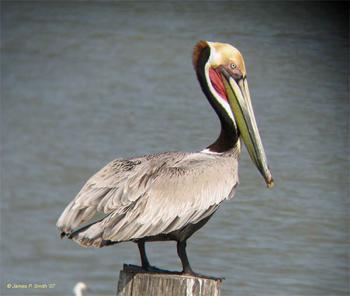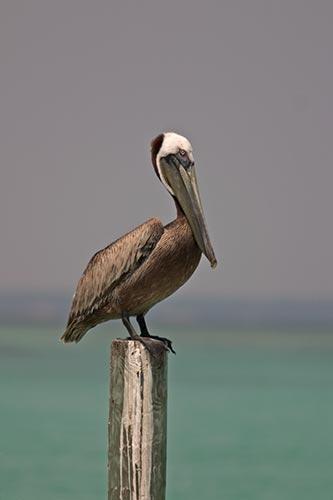The first image is the image on the left, the second image is the image on the right. Examine the images to the left and right. Is the description "In the left image, a pelican is facing right and sitting with its neck buried in its body." accurate? Answer yes or no. No. The first image is the image on the left, the second image is the image on the right. For the images shown, is this caption "Each image shows one pelican perched on a post, and at least one of the birds depicted is facing rightward." true? Answer yes or no. Yes. 